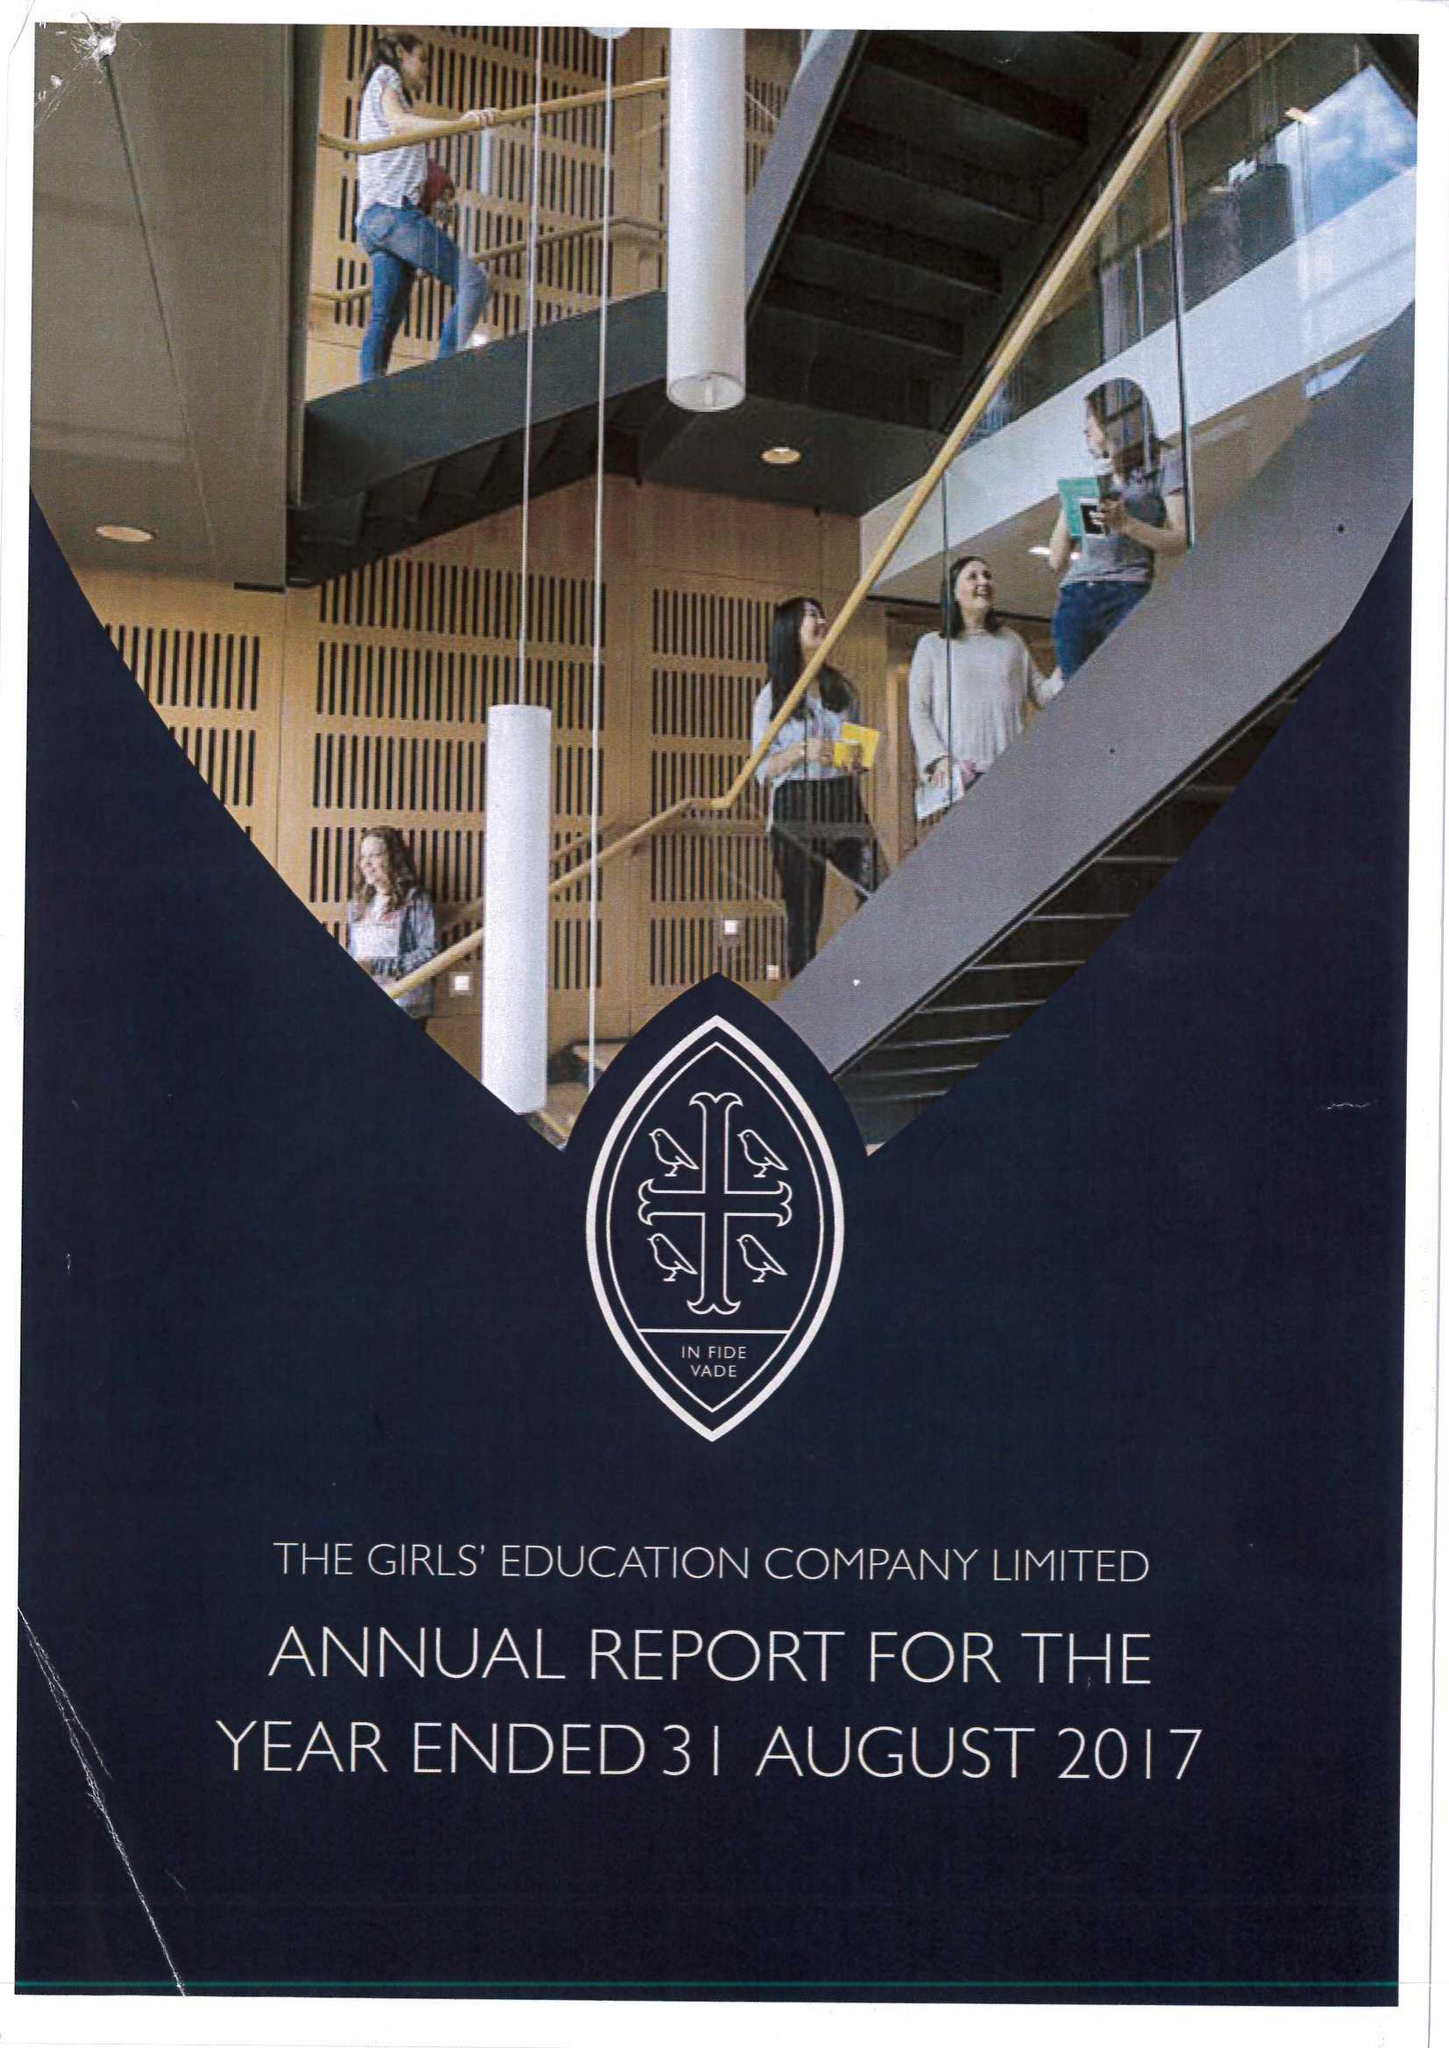What is the value for the charity_number?
Answer the question using a single word or phrase. 310638 